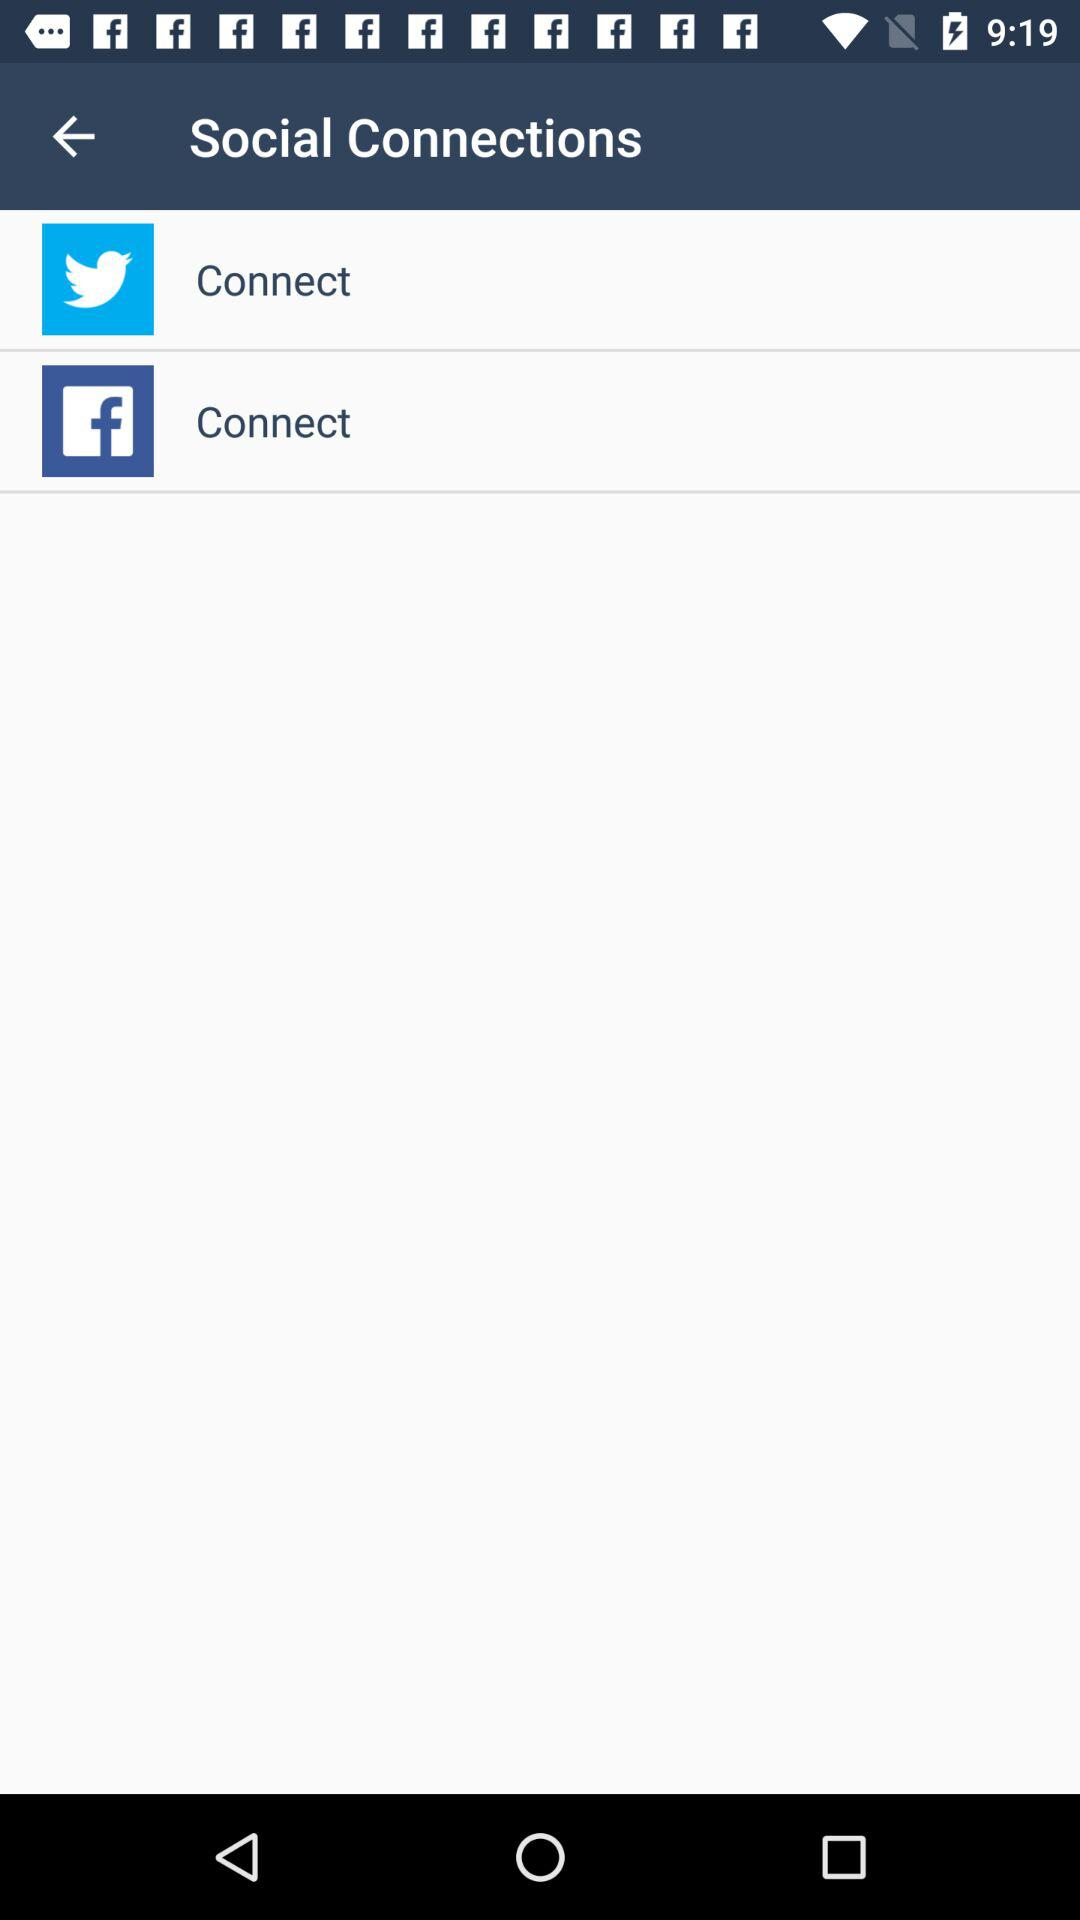How many social connections are there?
Answer the question using a single word or phrase. 2 